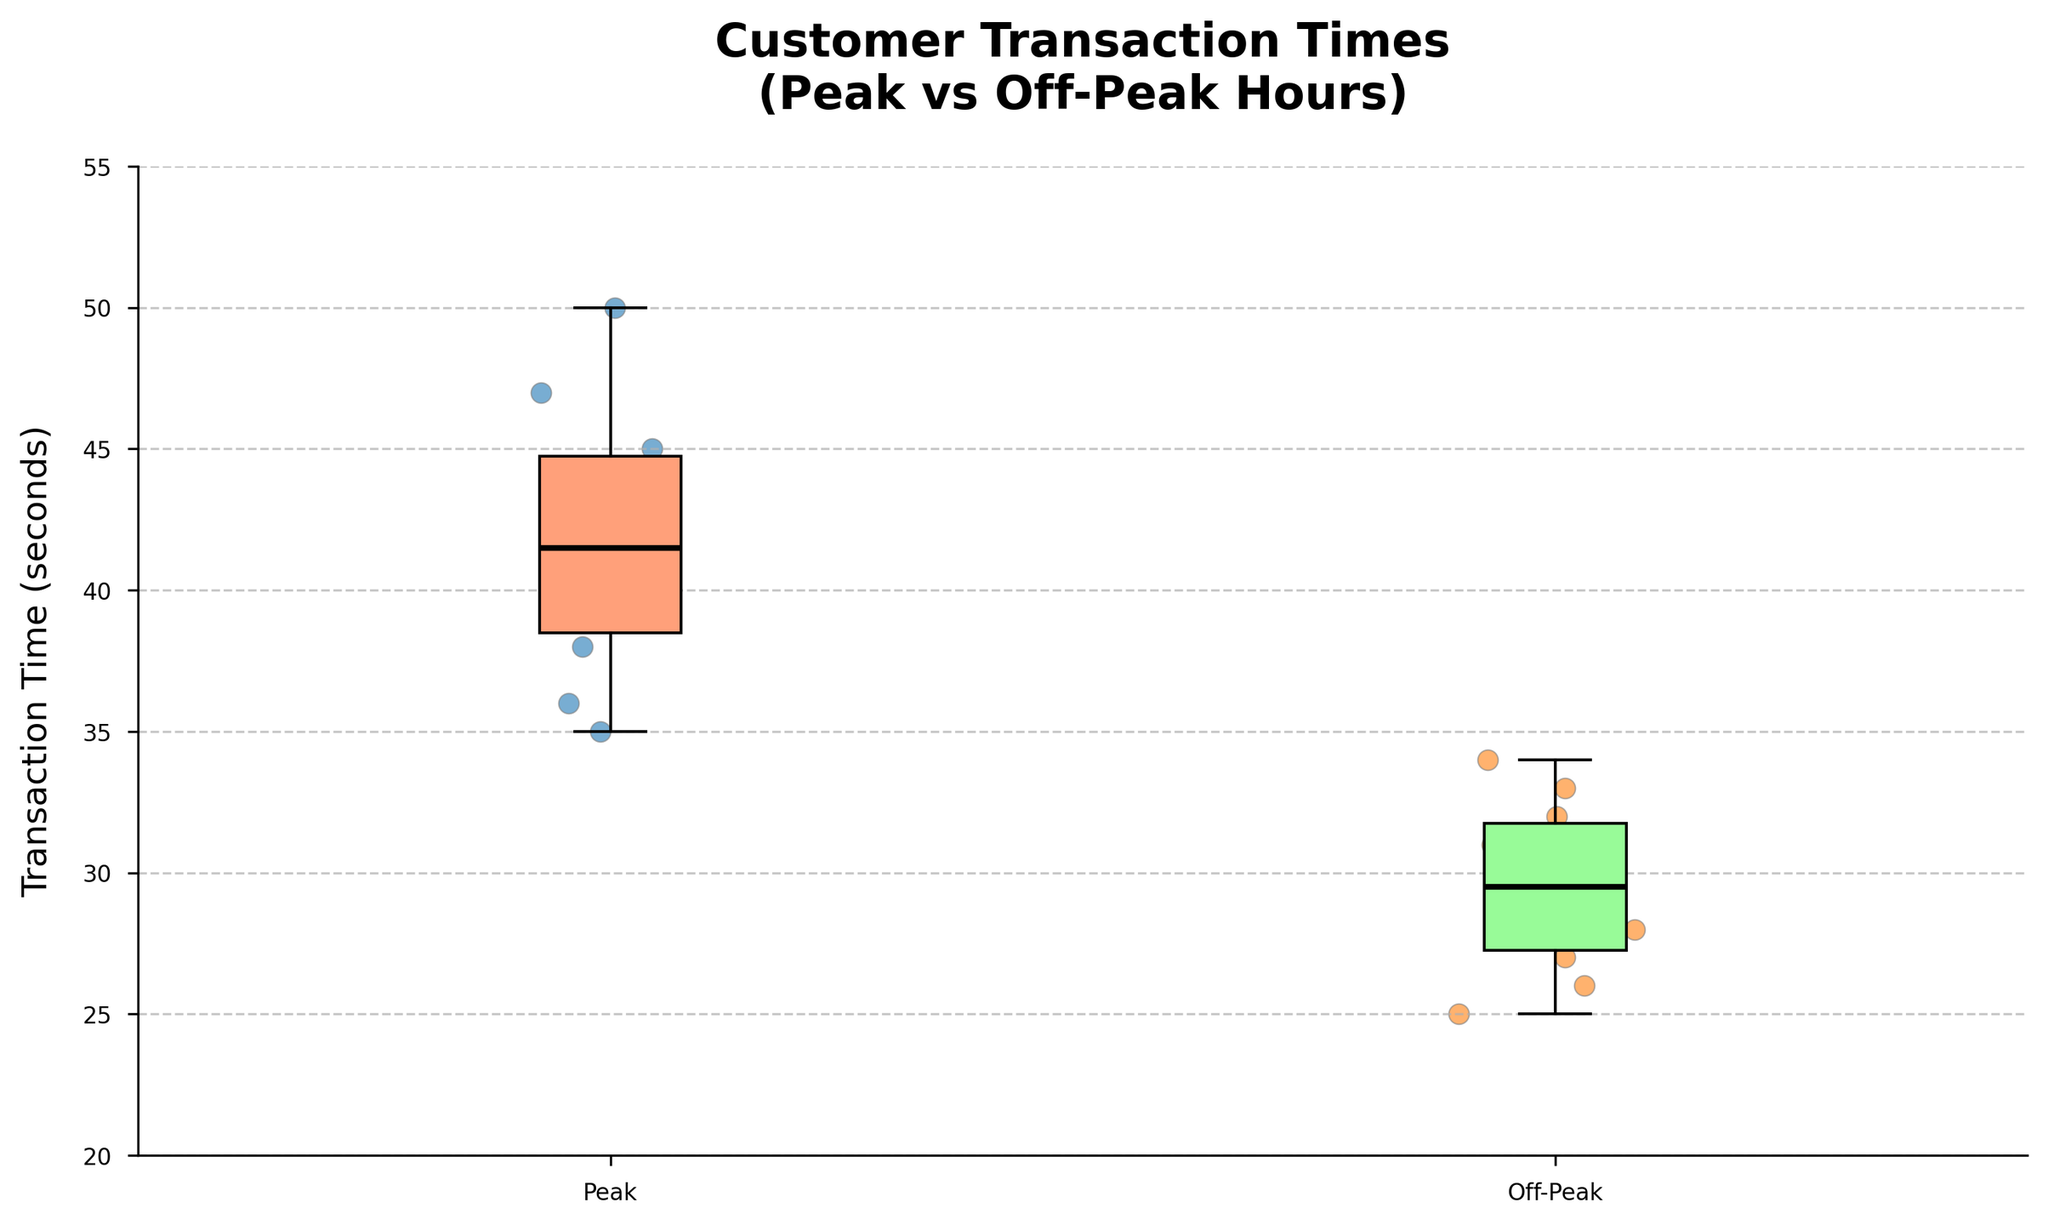What is the title of the plot? The title is usually found at the top of the plot, and in this case, it states the focus of the figure. The title here is "Customer Transaction Times (Peak vs Off-Peak Hours)"
Answer: Customer Transaction Times (Peak vs Off-Peak Hours) What does the x-axis represent in this plot? The x-axis typically labels the groups being compared. Here, it shows the periods "Peak" and "Off-Peak."
Answer: Periods What is the range of transaction times for Off-Peak hours? To find the range, look at the lower whisker and upper whisker of the Off-Peak box plot. The lower whisker is at 25 seconds and the upper whisker is at 34 seconds, giving a range of 34 - 25.
Answer: 9 seconds Which group has a higher median transaction time? The median is represented by the black line inside each box. For "Peak," it is higher than for "Off-Peak."
Answer: Peak hours What is the minimum transaction time during Peak hours? The minimum transaction time is represented by the bottom whisker of the Peak box plot. This is located at 35 seconds.
Answer: 35 seconds How does the interquartile range (IQR) compare between Peak and Off-Peak hours? The IQR is the range between the first quartile and the third quartile in each box plot. By visually comparing the length of the boxes, the Peak hours have a larger IQR than the Off-Peak hours.
Answer: Peak hours have a larger IQR Are there any outliers in either group? Outliers are typically represented by points outside the whiskers. In this plot, neither Peak nor Off-Peak groups have points outside their whiskers.
Answer: No What is the median transaction time for Off-Peak hours? The median is shown as the line inside the box of the Off-Peak group, located at about 30 seconds.
Answer: 30 seconds By how much does the median transaction time during Peak hours exceed the median during Off-Peak hours? The median in Peak is around 42 seconds, and in Off-Peak is 30 seconds. The difference is 42 - 30.
Answer: 12 seconds 